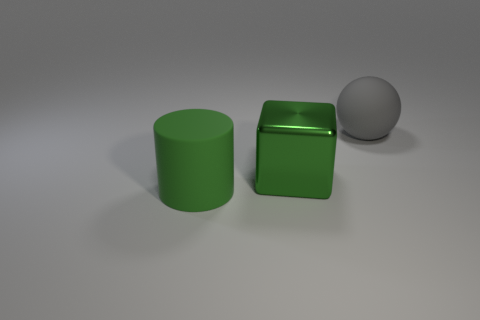How does the lighting in this image affect the appearance of the objects? The lighting in the image creates soft shadows and highlights that give depth to the objects, enhancing the 3-dimensional effect. The matte surface of the gray ball and the glossy finish of the green objects interact differently with the light, highlighting their textural differences. 